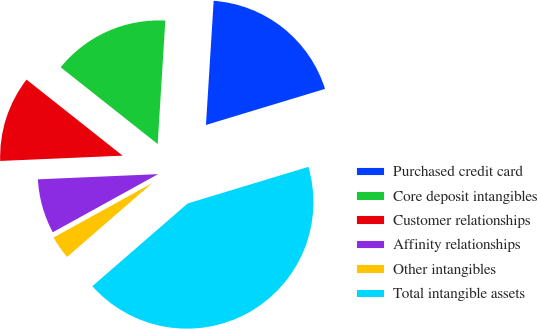Convert chart. <chart><loc_0><loc_0><loc_500><loc_500><pie_chart><fcel>Purchased credit card<fcel>Core deposit intangibles<fcel>Customer relationships<fcel>Affinity relationships<fcel>Other intangibles<fcel>Total intangible assets<nl><fcel>19.33%<fcel>15.33%<fcel>11.34%<fcel>7.34%<fcel>3.35%<fcel>43.3%<nl></chart> 